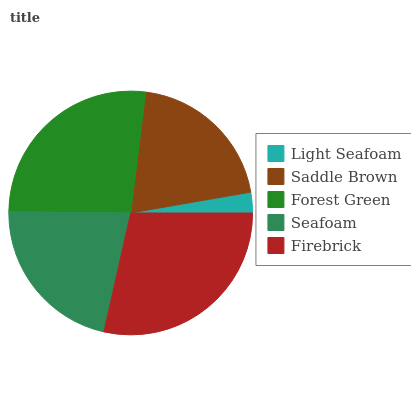Is Light Seafoam the minimum?
Answer yes or no. Yes. Is Firebrick the maximum?
Answer yes or no. Yes. Is Saddle Brown the minimum?
Answer yes or no. No. Is Saddle Brown the maximum?
Answer yes or no. No. Is Saddle Brown greater than Light Seafoam?
Answer yes or no. Yes. Is Light Seafoam less than Saddle Brown?
Answer yes or no. Yes. Is Light Seafoam greater than Saddle Brown?
Answer yes or no. No. Is Saddle Brown less than Light Seafoam?
Answer yes or no. No. Is Seafoam the high median?
Answer yes or no. Yes. Is Seafoam the low median?
Answer yes or no. Yes. Is Saddle Brown the high median?
Answer yes or no. No. Is Saddle Brown the low median?
Answer yes or no. No. 